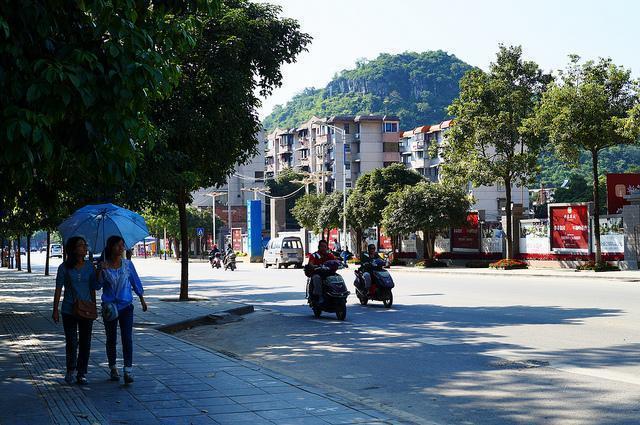What protection does an umbrella offer here?
Pick the correct solution from the four options below to address the question.
Options: Locusts, nuclear fallout, rain, sun shade. Sun shade. 